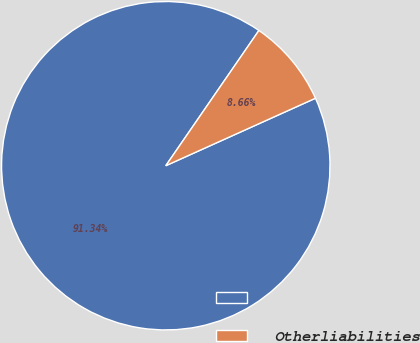Convert chart. <chart><loc_0><loc_0><loc_500><loc_500><pie_chart><ecel><fcel>Otherliabilities<nl><fcel>91.34%<fcel>8.66%<nl></chart> 